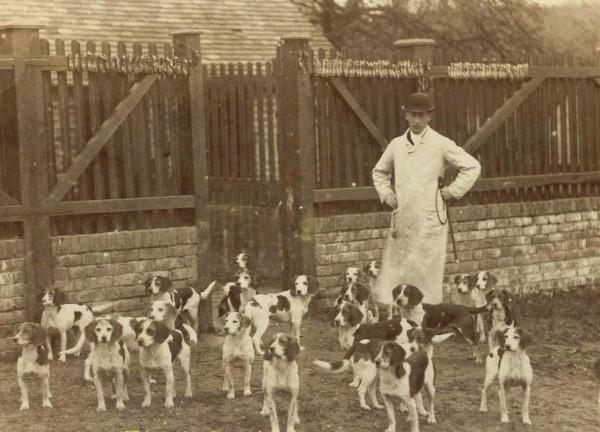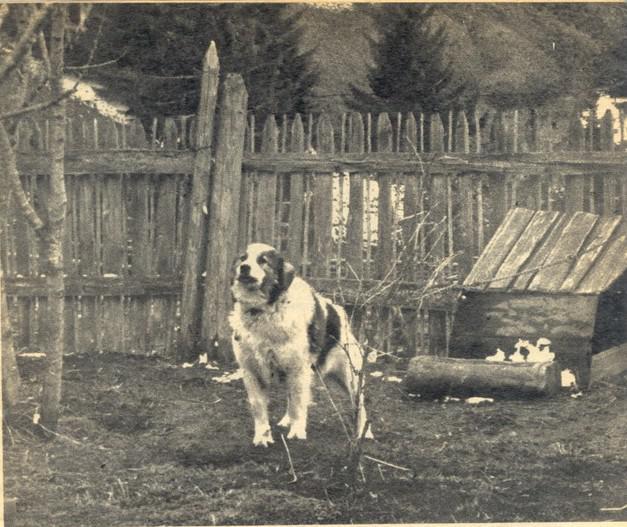The first image is the image on the left, the second image is the image on the right. For the images displayed, is the sentence "There is exactly one dog in one of the images." factually correct? Answer yes or no. Yes. 